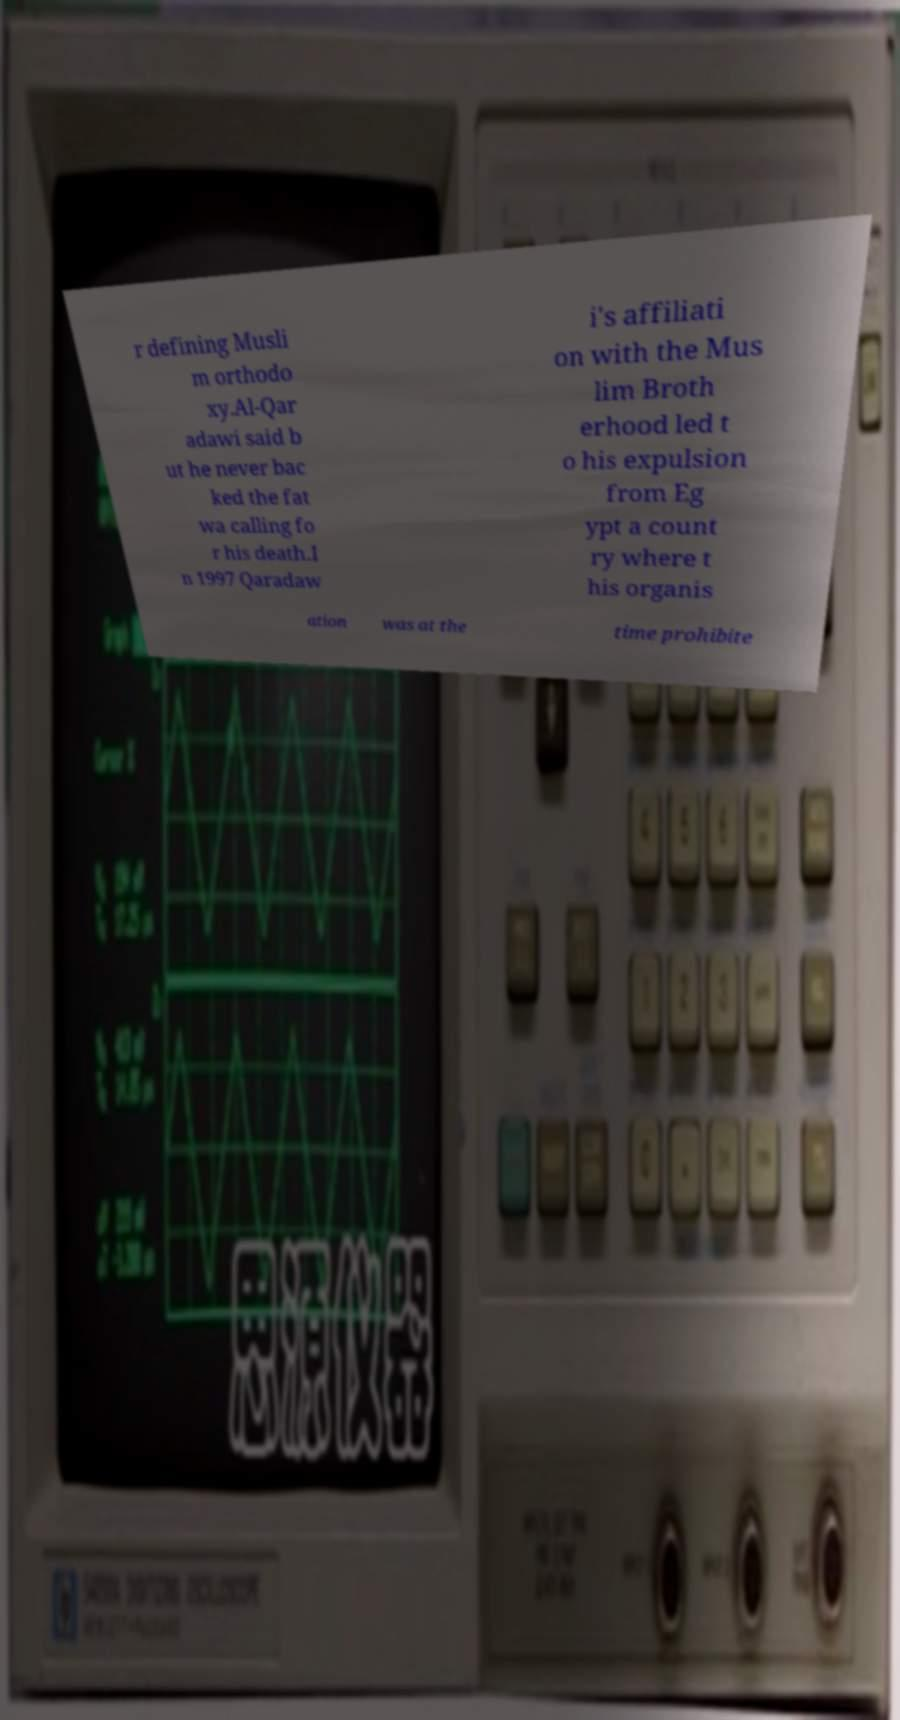Please identify and transcribe the text found in this image. r defining Musli m orthodo xy.Al-Qar adawi said b ut he never bac ked the fat wa calling fo r his death.I n 1997 Qaradaw i's affiliati on with the Mus lim Broth erhood led t o his expulsion from Eg ypt a count ry where t his organis ation was at the time prohibite 